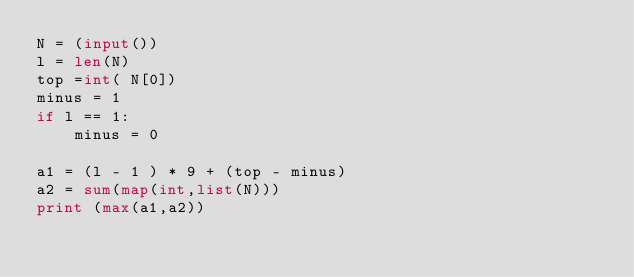Convert code to text. <code><loc_0><loc_0><loc_500><loc_500><_Python_>N = (input())
l = len(N)
top =int( N[0])
minus = 1
if l == 1:
    minus = 0

a1 = (l - 1 ) * 9 + (top - minus)
a2 = sum(map(int,list(N)))
print (max(a1,a2))
</code> 